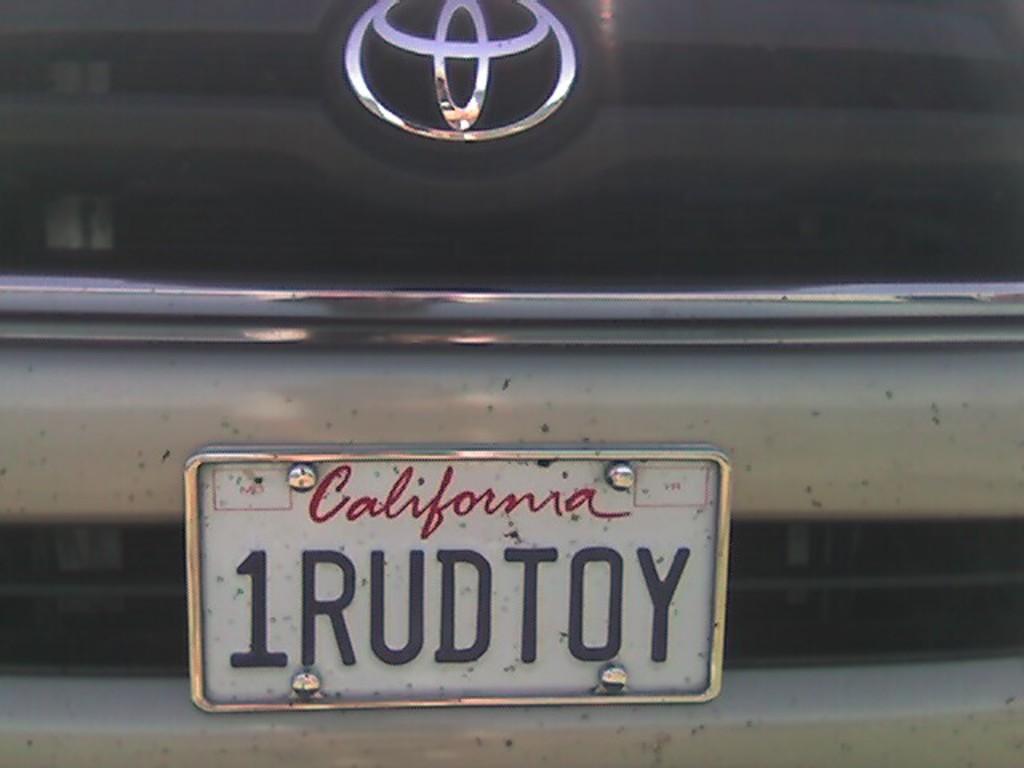What state is this car registered in?
Ensure brevity in your answer.  California. 